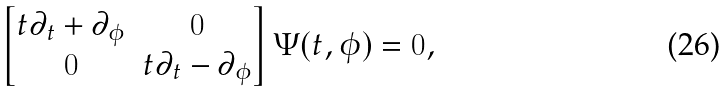<formula> <loc_0><loc_0><loc_500><loc_500>\begin{bmatrix} t \partial _ { t } + \partial _ { \phi } & 0 \\ 0 & t \partial _ { t } - \partial _ { \phi } \end{bmatrix} \Psi ( t , \phi ) = 0 ,</formula> 